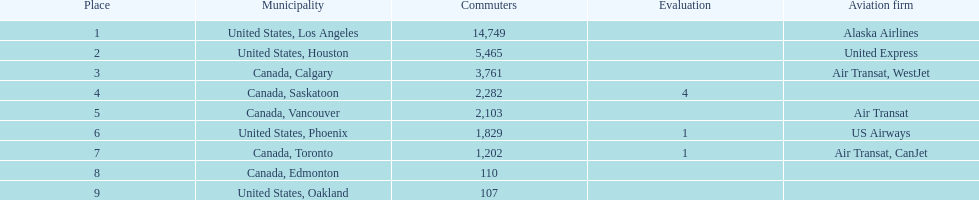How many airlines have a steady ranking? 4. 